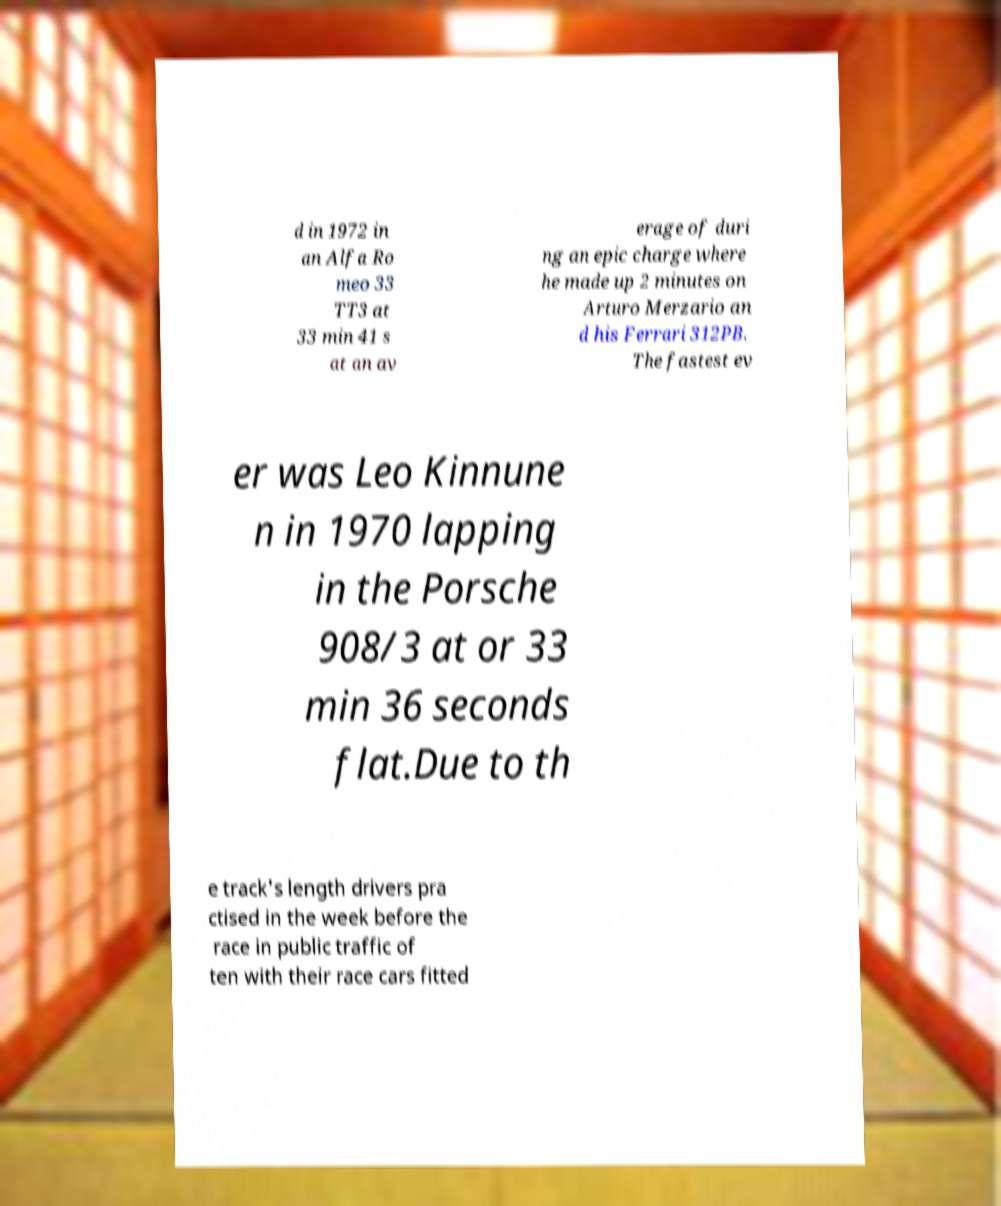Please read and relay the text visible in this image. What does it say? d in 1972 in an Alfa Ro meo 33 TT3 at 33 min 41 s at an av erage of duri ng an epic charge where he made up 2 minutes on Arturo Merzario an d his Ferrari 312PB. The fastest ev er was Leo Kinnune n in 1970 lapping in the Porsche 908/3 at or 33 min 36 seconds flat.Due to th e track's length drivers pra ctised in the week before the race in public traffic of ten with their race cars fitted 